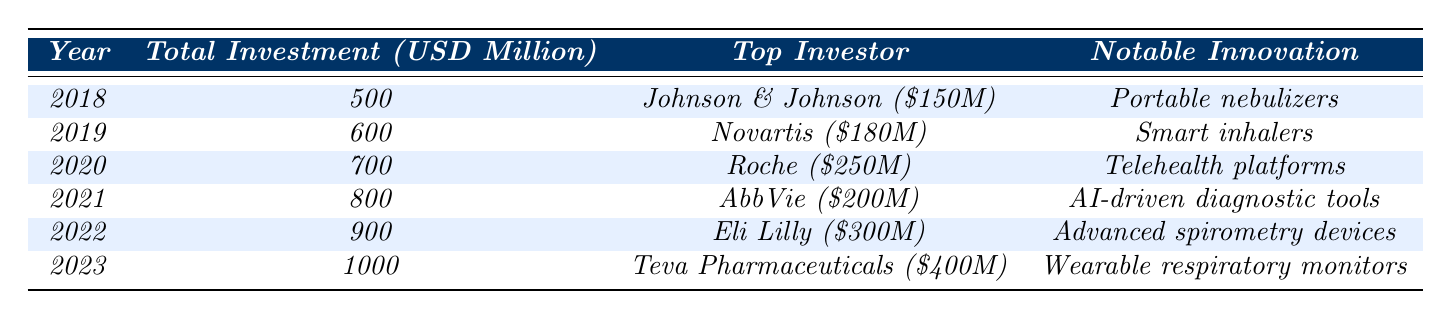What was the total investment in respiratory medical technologies in 2020? The table states that the total investment for the year 2020 was 700 million USD.
Answer: 700 million USD Which company invested the most in 2023? In 2023, the highest investment was made by Teva Pharmaceuticals, with an investment of 400 million USD.
Answer: Teva Pharmaceuticals How much did Eli Lilly invest in 2022? According to the table, Eli Lilly invested 300 million USD in 2022.
Answer: 300 million USD What is the difference in total investment between 2018 and 2023? The total investment in 2018 was 500 million USD and in 2023 it was 1000 million USD. The difference is 1000 - 500 = 500 million USD.
Answer: 500 million USD Was there any year when total investment was below 600 million USD? Yes, in 2018, the total investment was 500 million USD, which is below 600 million USD.
Answer: Yes Which year had the highest investment, and how much was that investment? The highest investment occurred in 2023, amounting to 1000 million USD.
Answer: 2023, 1000 million USD What notable innovation was described for the year 2021? The table lists "AI-driven diagnostic tools" as the notable innovation for the year 2021.
Answer: AI-driven diagnostic tools If we consider the investments of the top three investors in 2019, what is their combined investment? The top three investors in 2019 were Novartis with 180 million, Medtronic with 130 million, and Philips with 120 million. Combined, this is 180 + 130 + 120 = 430 million USD.
Answer: 430 million USD Did investment trends show a consistent increase from 2018 to 2023? Yes, the total investment increased each year from 500 million in 2018 to 1000 million in 2023, indicating a consistent trend of growth.
Answer: Yes Which year saw the introduction of telehealth platforms for pulmonary rehabilitation, and what was the investment amount that year? Telehealth platforms for pulmonary rehabilitation were introduced in 2020, which had a total investment of 700 million USD.
Answer: 2020, 700 million USD 